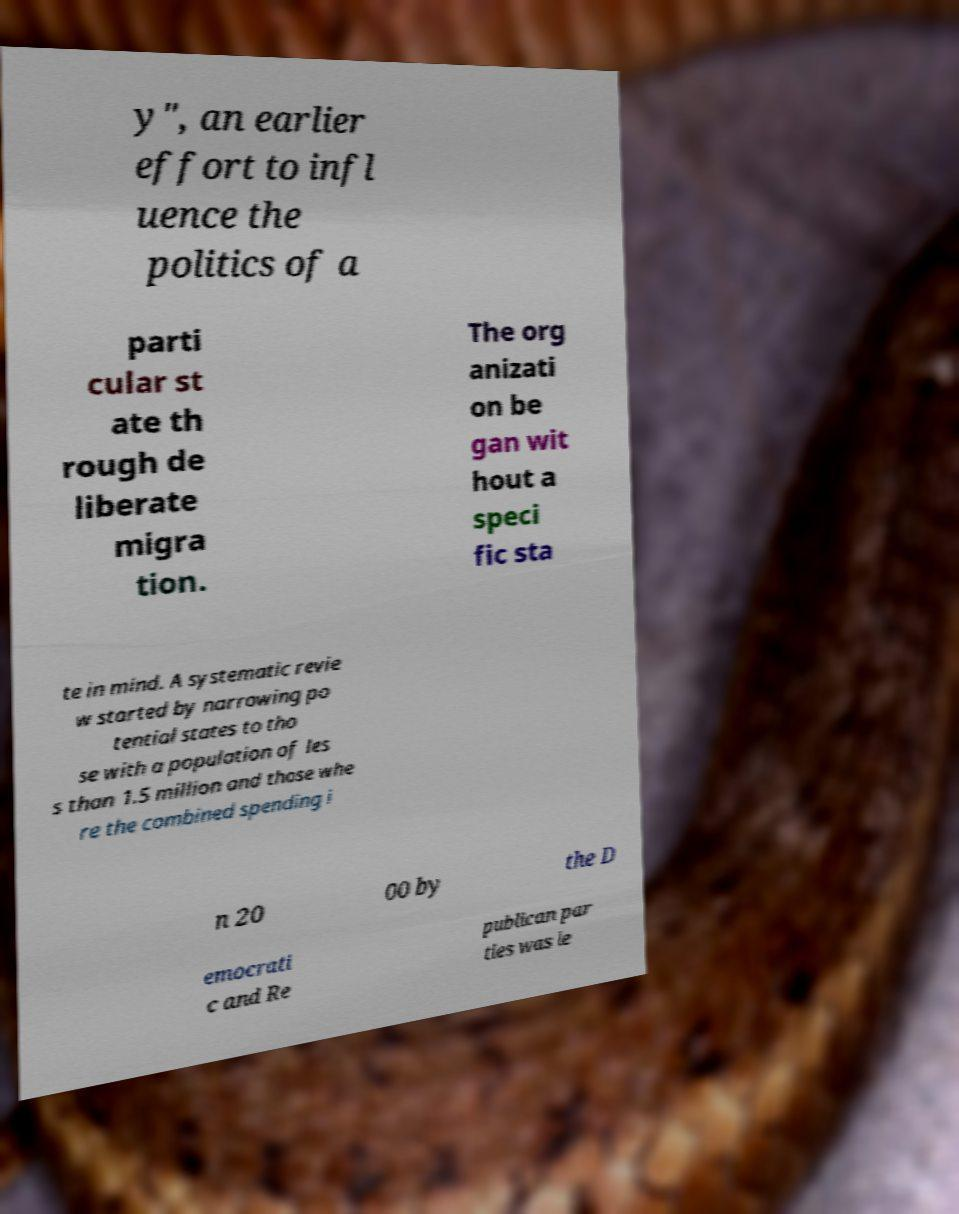Could you assist in decoding the text presented in this image and type it out clearly? y", an earlier effort to infl uence the politics of a parti cular st ate th rough de liberate migra tion. The org anizati on be gan wit hout a speci fic sta te in mind. A systematic revie w started by narrowing po tential states to tho se with a population of les s than 1.5 million and those whe re the combined spending i n 20 00 by the D emocrati c and Re publican par ties was le 